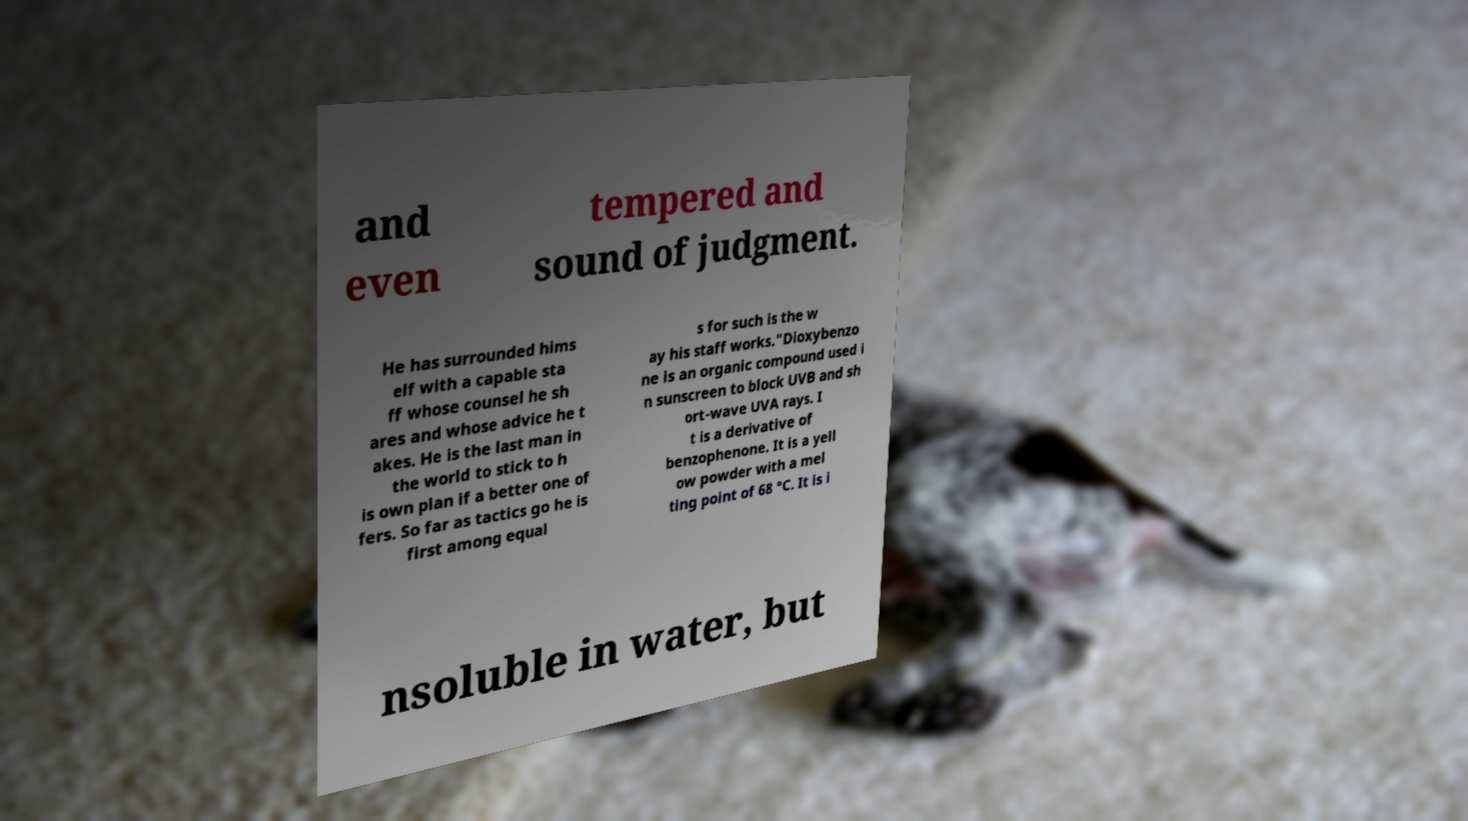I need the written content from this picture converted into text. Can you do that? and even tempered and sound of judgment. He has surrounded hims elf with a capable sta ff whose counsel he sh ares and whose advice he t akes. He is the last man in the world to stick to h is own plan if a better one of fers. So far as tactics go he is first among equal s for such is the w ay his staff works."Dioxybenzo ne is an organic compound used i n sunscreen to block UVB and sh ort-wave UVA rays. I t is a derivative of benzophenone. It is a yell ow powder with a mel ting point of 68 °C. It is i nsoluble in water, but 